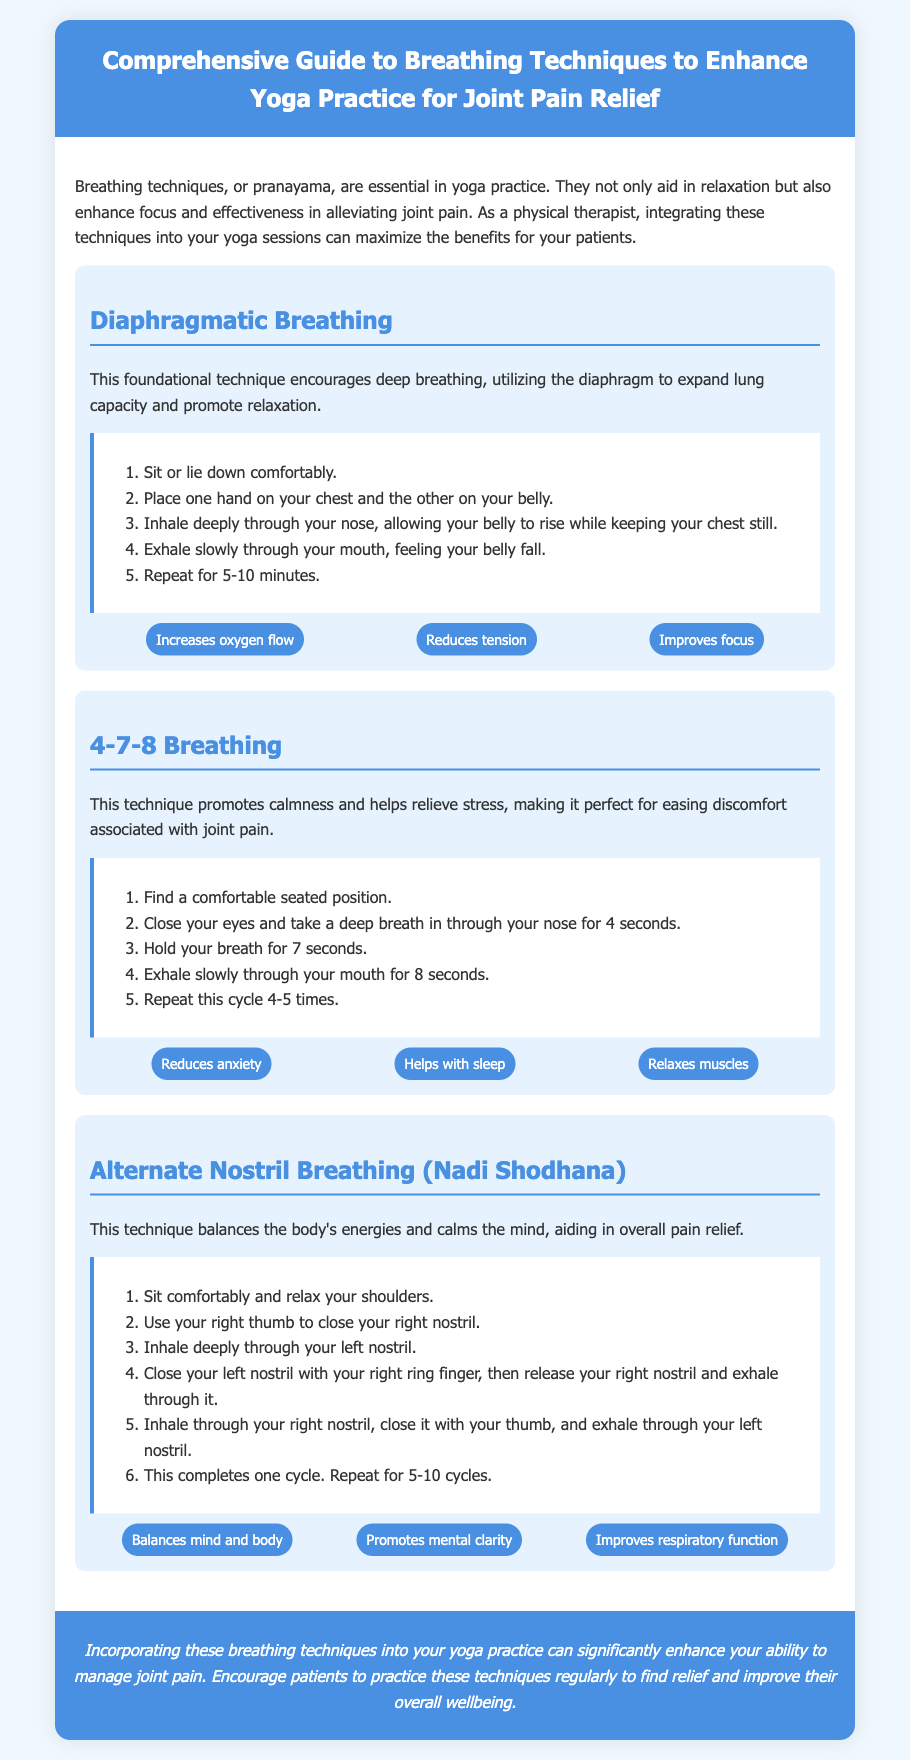What is the title of the document? The title is stated at the top of the document as a header.
Answer: Comprehensive Guide to Breathing Techniques to Enhance Yoga Practice for Joint Pain Relief What is the first breathing technique mentioned? The first technique listed under techniques is the one that follows the header for breathing techniques.
Answer: Diaphragmatic Breathing How long should you practice Diaphragmatic Breathing? The duration is mentioned in the steps for this technique.
Answer: 5-10 minutes How many cycles are recommended for Alternate Nostril Breathing? The number of cycles is mentioned in the steps for this technique.
Answer: 5-10 cycles What is a benefit of 4-7-8 Breathing? Benefits for this technique are listed after the steps.
Answer: Reduces anxiety What action should you take during the first step of 4-7-8 Breathing? The first step describes the action to be taken when beginning this technique.
Answer: Find a comfortable seated position What can incorporating breathing techniques into yoga practice enhance? The document talks about benefits of these techniques at the end.
Answer: Ability to manage joint pain What is one reason to practice breathing techniques regularly? The conclusion emphasizes a particular benefit of regular practice.
Answer: Improve their overall wellbeing 